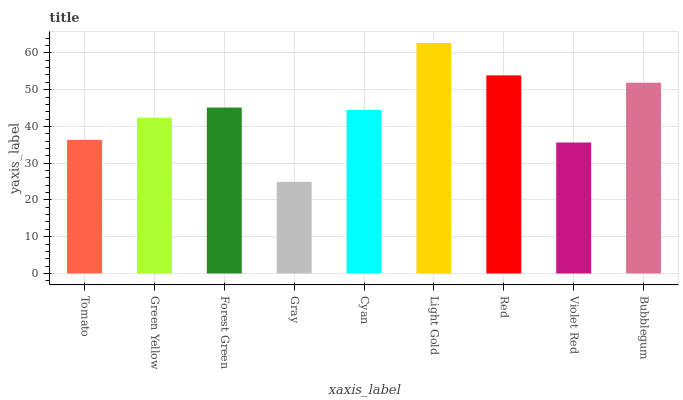Is Gray the minimum?
Answer yes or no. Yes. Is Light Gold the maximum?
Answer yes or no. Yes. Is Green Yellow the minimum?
Answer yes or no. No. Is Green Yellow the maximum?
Answer yes or no. No. Is Green Yellow greater than Tomato?
Answer yes or no. Yes. Is Tomato less than Green Yellow?
Answer yes or no. Yes. Is Tomato greater than Green Yellow?
Answer yes or no. No. Is Green Yellow less than Tomato?
Answer yes or no. No. Is Cyan the high median?
Answer yes or no. Yes. Is Cyan the low median?
Answer yes or no. Yes. Is Violet Red the high median?
Answer yes or no. No. Is Violet Red the low median?
Answer yes or no. No. 